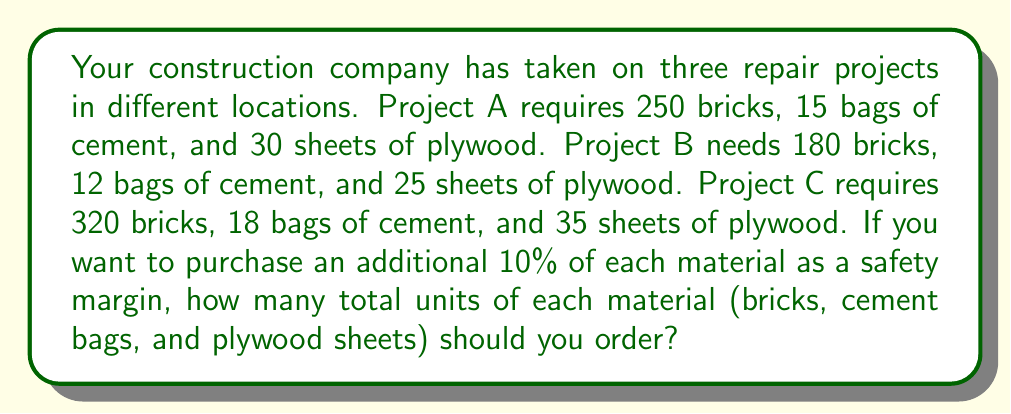What is the answer to this math problem? Let's solve this problem step by step:

1. Calculate the total number of each material needed for all projects:

   Bricks: $250 + 180 + 320 = 750$
   Cement bags: $15 + 12 + 18 = 45$
   Plywood sheets: $30 + 25 + 35 = 90$

2. Calculate the 10% safety margin for each material:

   Bricks: $750 \times 0.10 = 75$
   Cement bags: $45 \times 0.10 = 4.5$ (round up to 5)
   Plywood sheets: $90 \times 0.10 = 9$

3. Add the safety margin to the total for each material:

   Bricks: $750 + 75 = 825$
   Cement bags: $45 + 5 = 50$
   Plywood sheets: $90 + 9 = 99$

Therefore, you should order 825 bricks, 50 bags of cement, and 99 sheets of plywood.
Answer: 825 bricks, 50 cement bags, 99 plywood sheets 